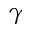Convert formula to latex. <formula><loc_0><loc_0><loc_500><loc_500>\gamma</formula> 